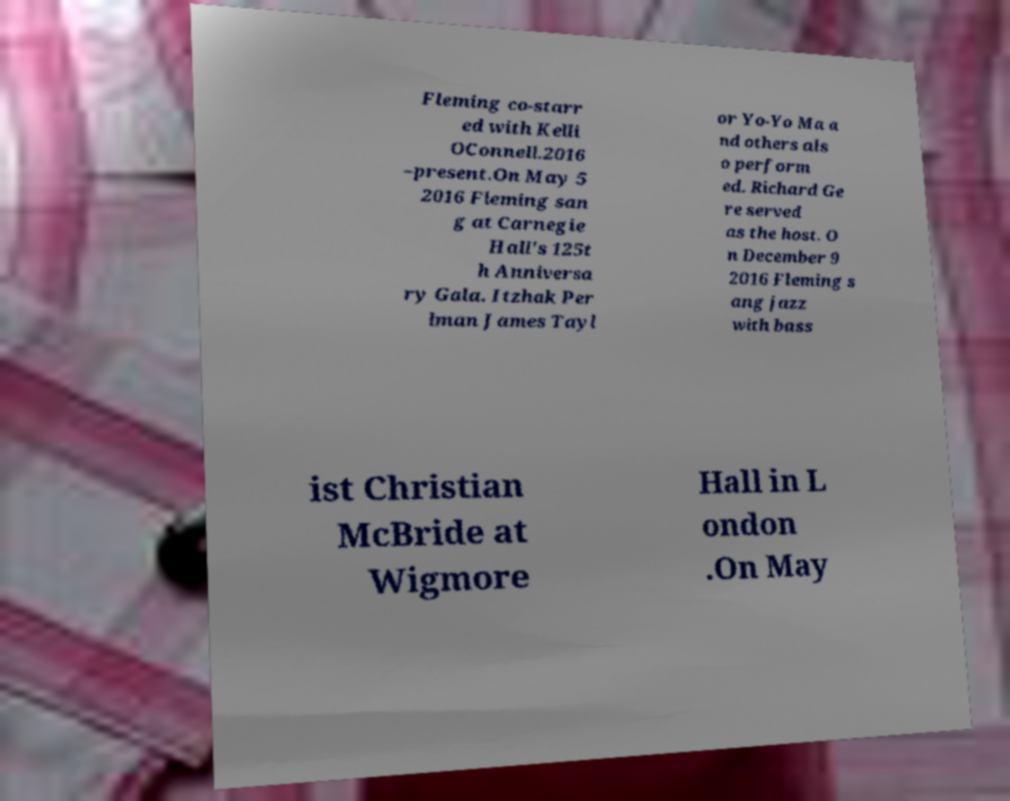Could you assist in decoding the text presented in this image and type it out clearly? Fleming co-starr ed with Kelli OConnell.2016 –present.On May 5 2016 Fleming san g at Carnegie Hall's 125t h Anniversa ry Gala. Itzhak Per lman James Tayl or Yo-Yo Ma a nd others als o perform ed. Richard Ge re served as the host. O n December 9 2016 Fleming s ang jazz with bass ist Christian McBride at Wigmore Hall in L ondon .On May 